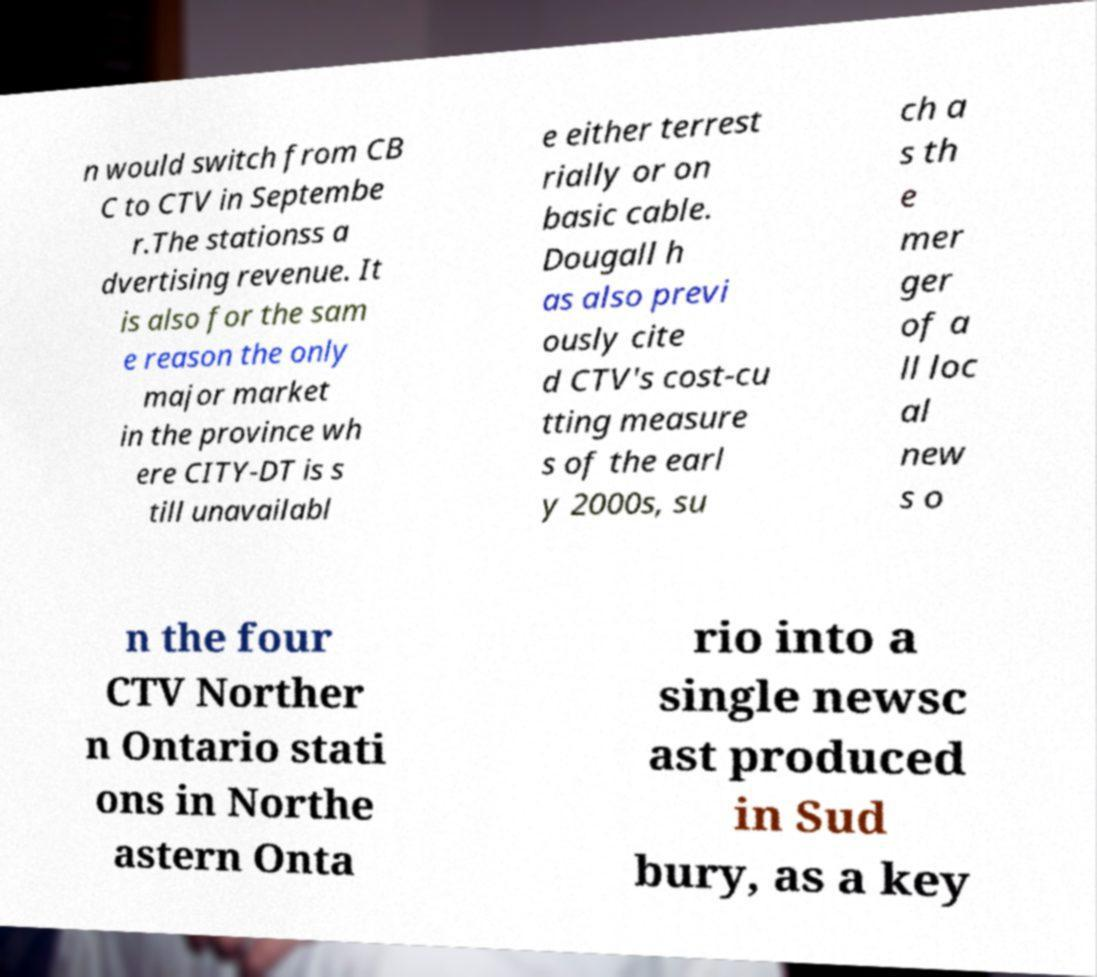Please read and relay the text visible in this image. What does it say? n would switch from CB C to CTV in Septembe r.The stationss a dvertising revenue. It is also for the sam e reason the only major market in the province wh ere CITY-DT is s till unavailabl e either terrest rially or on basic cable. Dougall h as also previ ously cite d CTV's cost-cu tting measure s of the earl y 2000s, su ch a s th e mer ger of a ll loc al new s o n the four CTV Norther n Ontario stati ons in Northe astern Onta rio into a single newsc ast produced in Sud bury, as a key 